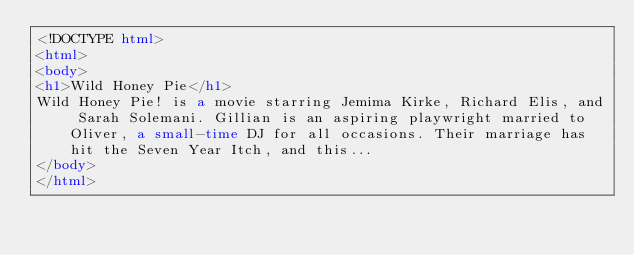<code> <loc_0><loc_0><loc_500><loc_500><_HTML_><!DOCTYPE html>
<html>
<body>
<h1>Wild Honey Pie</h1>
Wild Honey Pie! is a movie starring Jemima Kirke, Richard Elis, and Sarah Solemani. Gillian is an aspiring playwright married to Oliver, a small-time DJ for all occasions. Their marriage has hit the Seven Year Itch, and this...
</body>
</html></code> 